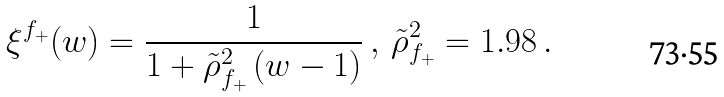<formula> <loc_0><loc_0><loc_500><loc_500>\xi ^ { f _ { + } } ( w ) = \frac { 1 } { 1 + \tilde { \rho } ^ { 2 } _ { f _ { + } } \, ( w - 1 ) } \, , \, \tilde { \rho } ^ { 2 } _ { f _ { + } } = 1 . 9 8 \, .</formula> 